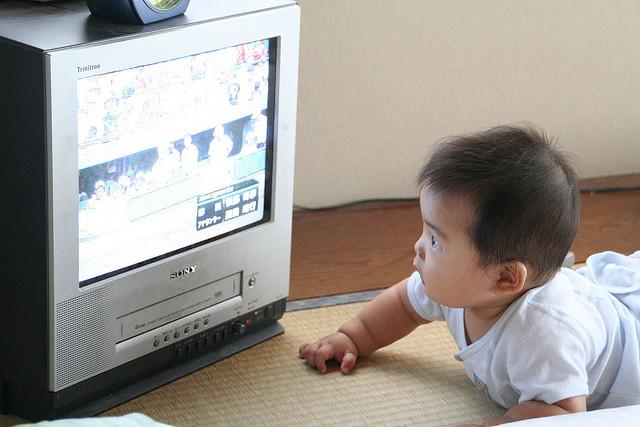What is the brand of this television?
Quick response, please. Sony. Is the baby asleep?
Answer briefly. No. How old is the boy?
Quick response, please. 1. What goes into the rectangle below the logo?
Give a very brief answer. Vhs tape. What game console is that?
Quick response, please. Wii. 